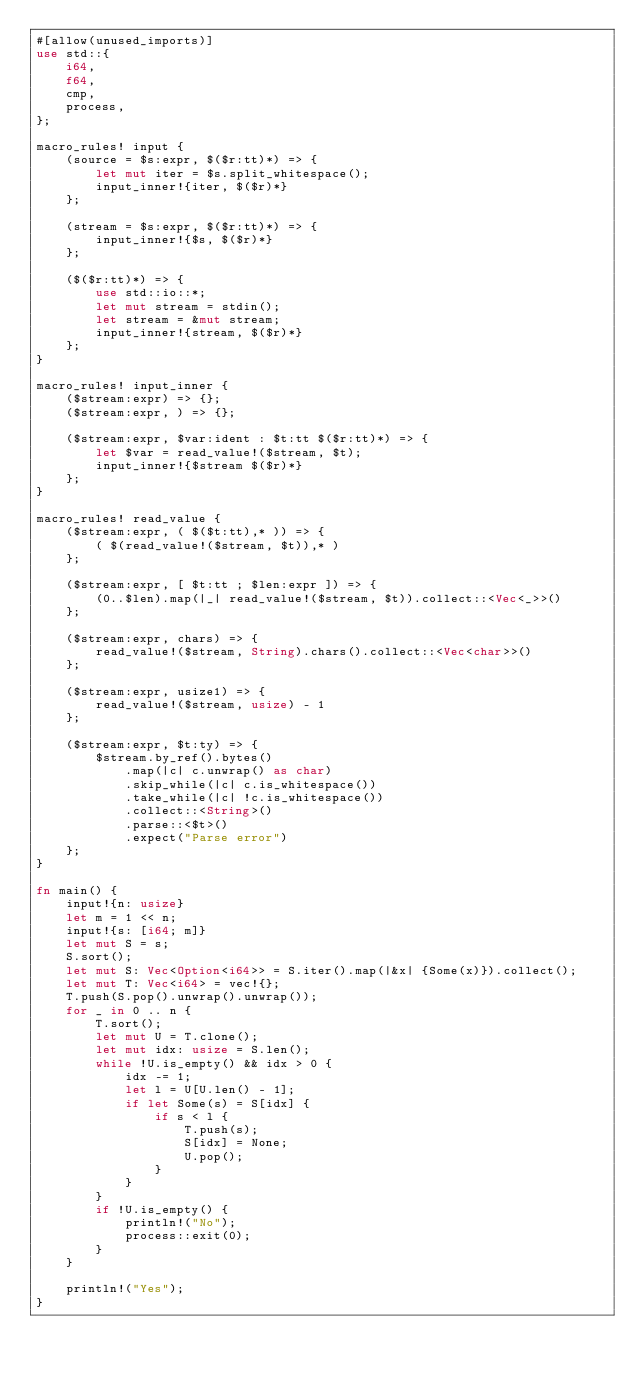<code> <loc_0><loc_0><loc_500><loc_500><_Rust_>#[allow(unused_imports)]
use std::{
    i64,
    f64,
    cmp,
    process,
};

macro_rules! input {
    (source = $s:expr, $($r:tt)*) => {
        let mut iter = $s.split_whitespace();
        input_inner!{iter, $($r)*}
    };

    (stream = $s:expr, $($r:tt)*) => {
        input_inner!{$s, $($r)*}
    };

    ($($r:tt)*) => {
        use std::io::*;
        let mut stream = stdin();
        let stream = &mut stream;
        input_inner!{stream, $($r)*}
    };
}

macro_rules! input_inner {
    ($stream:expr) => {};
    ($stream:expr, ) => {};

    ($stream:expr, $var:ident : $t:tt $($r:tt)*) => {
        let $var = read_value!($stream, $t);
        input_inner!{$stream $($r)*}
    };
}

macro_rules! read_value {
    ($stream:expr, ( $($t:tt),* )) => {
        ( $(read_value!($stream, $t)),* )
    };

    ($stream:expr, [ $t:tt ; $len:expr ]) => {
        (0..$len).map(|_| read_value!($stream, $t)).collect::<Vec<_>>()
    };

    ($stream:expr, chars) => {
        read_value!($stream, String).chars().collect::<Vec<char>>()
    };

    ($stream:expr, usize1) => {
        read_value!($stream, usize) - 1
    };

    ($stream:expr, $t:ty) => {
        $stream.by_ref().bytes()
            .map(|c| c.unwrap() as char)
            .skip_while(|c| c.is_whitespace())
            .take_while(|c| !c.is_whitespace())
            .collect::<String>()
            .parse::<$t>()
            .expect("Parse error")
    };
}

fn main() {
    input!{n: usize}
    let m = 1 << n;
    input!{s: [i64; m]}
    let mut S = s;
    S.sort();
    let mut S: Vec<Option<i64>> = S.iter().map(|&x| {Some(x)}).collect();
    let mut T: Vec<i64> = vec!{};
    T.push(S.pop().unwrap().unwrap());
    for _ in 0 .. n {
        T.sort();
        let mut U = T.clone();
        let mut idx: usize = S.len();
        while !U.is_empty() && idx > 0 {
            idx -= 1;
            let l = U[U.len() - 1];
            if let Some(s) = S[idx] {
                if s < l {
                    T.push(s);
                    S[idx] = None;
                    U.pop();
                }
            }
        }
        if !U.is_empty() {
            println!("No");
            process::exit(0);
        }
    }

    println!("Yes");
}</code> 